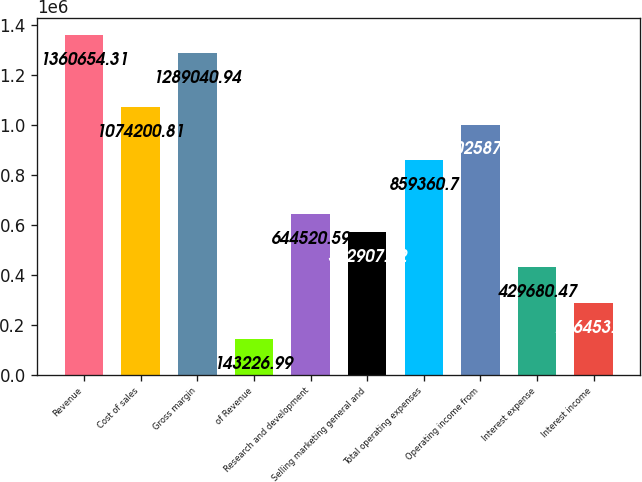<chart> <loc_0><loc_0><loc_500><loc_500><bar_chart><fcel>Revenue<fcel>Cost of sales<fcel>Gross margin<fcel>of Revenue<fcel>Research and development<fcel>Selling marketing general and<fcel>Total operating expenses<fcel>Operating income from<fcel>Interest expense<fcel>Interest income<nl><fcel>1.36065e+06<fcel>1.0742e+06<fcel>1.28904e+06<fcel>143227<fcel>644521<fcel>572907<fcel>859361<fcel>1.00259e+06<fcel>429680<fcel>286454<nl></chart> 